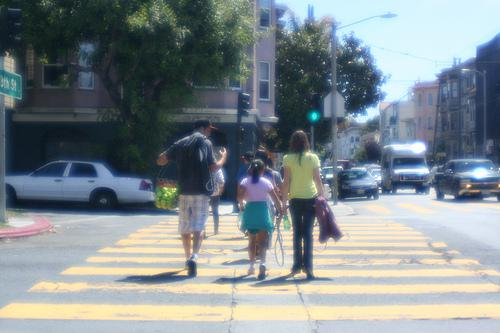Question: what is the street made of?
Choices:
A. Pavement.
B. Concrete.
C. Dirt.
D. Gravel.
Answer with the letter. Answer: A Question: what color are the trees?
Choices:
A. Yellow.
B. White.
C. Brown.
D. Green.
Answer with the letter. Answer: D Question: what color is the crosswalk?
Choices:
A. Yellow.
B. White.
C. Red.
D. Orange.
Answer with the letter. Answer: A 